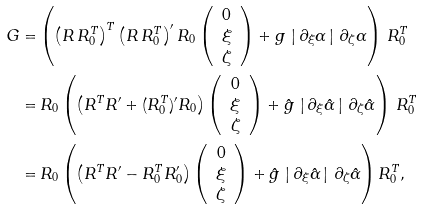Convert formula to latex. <formula><loc_0><loc_0><loc_500><loc_500>G = & \left ( \left ( R \, R _ { 0 } ^ { T } \right ) ^ { T } \left ( R \, R _ { 0 } ^ { T } \right ) ^ { \prime } R _ { 0 } \left ( \begin{array} { c } 0 \\ \xi \\ \zeta \end{array} \right ) + g \, \left | \, \partial _ { \xi } \alpha \, \right | \, \partial _ { \zeta } \alpha \right ) \, R ^ { T } _ { 0 } \\ = & \, R _ { 0 } \left ( \left ( R ^ { T } R ^ { \prime } + ( R _ { 0 } ^ { T } ) ^ { \prime } R _ { 0 } \right ) \left ( \begin{array} { c } 0 \\ \xi \\ \zeta \end{array} \right ) + \hat { g } \, \left | \, \partial _ { \xi } \hat { \alpha } \, \right | \, \partial _ { \zeta } \hat { \alpha } \right ) \, R _ { 0 } ^ { T } \\ = & \, R _ { 0 } \left ( \left ( R ^ { T } R ^ { \prime } - R _ { 0 } ^ { T } R _ { 0 } ^ { \prime } \right ) \left ( \begin{array} { c } 0 \\ \xi \\ \zeta \end{array} \right ) + \hat { g } \, \left | \, \partial _ { \xi } \hat { \alpha } \, \right | \, \partial _ { \zeta } \hat { \alpha } \right ) R _ { 0 } ^ { T } ,</formula> 